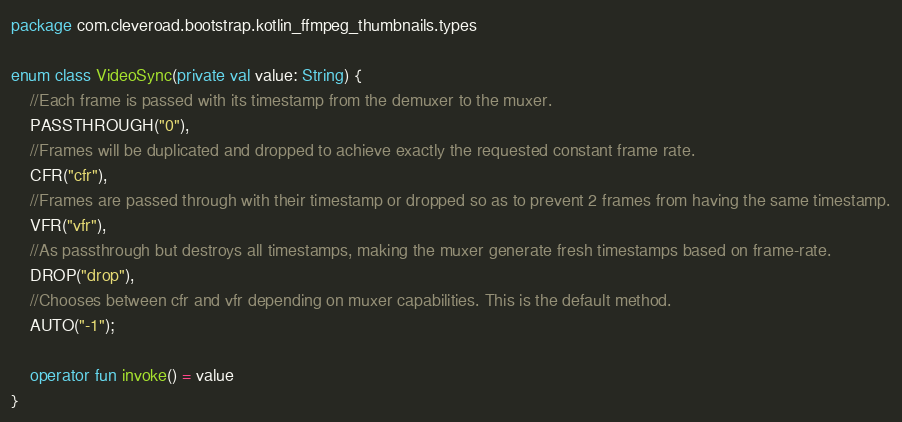Convert code to text. <code><loc_0><loc_0><loc_500><loc_500><_Kotlin_>package com.cleveroad.bootstrap.kotlin_ffmpeg_thumbnails.types

enum class VideoSync(private val value: String) {
    //Each frame is passed with its timestamp from the demuxer to the muxer.
    PASSTHROUGH("0"),
    //Frames will be duplicated and dropped to achieve exactly the requested constant frame rate.
    CFR("cfr"),
    //Frames are passed through with their timestamp or dropped so as to prevent 2 frames from having the same timestamp.
    VFR("vfr"),
    //As passthrough but destroys all timestamps, making the muxer generate fresh timestamps based on frame-rate.
    DROP("drop"),
    //Chooses between cfr and vfr depending on muxer capabilities. This is the default method.
    AUTO("-1");

    operator fun invoke() = value
}</code> 